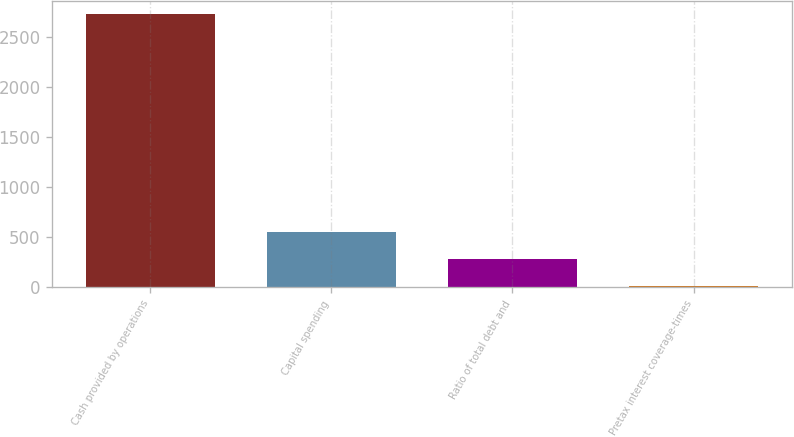Convert chart to OTSL. <chart><loc_0><loc_0><loc_500><loc_500><bar_chart><fcel>Cash provided by operations<fcel>Capital spending<fcel>Ratio of total debt and<fcel>Pretax interest coverage-times<nl><fcel>2726.2<fcel>554.44<fcel>282.97<fcel>11.5<nl></chart> 